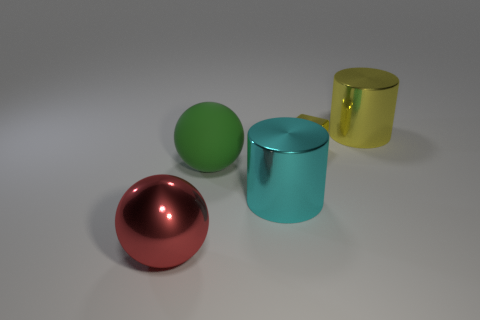Is there any other thing that has the same size as the cube?
Your answer should be very brief. No. What size is the shiny thing left of the big green thing?
Make the answer very short. Large. Is the number of small yellow metallic cubes less than the number of large yellow blocks?
Ensure brevity in your answer.  No. Is there a large matte object that has the same color as the small metallic block?
Provide a short and direct response. No. There is a large thing that is both to the right of the green thing and in front of the large yellow cylinder; what is its shape?
Give a very brief answer. Cylinder. There is a yellow thing that is to the left of the thing that is behind the metal cube; what is its shape?
Ensure brevity in your answer.  Cube. Is the shape of the green object the same as the tiny metal object?
Give a very brief answer. No. What material is the cylinder that is the same color as the tiny metallic object?
Your answer should be very brief. Metal. Do the small shiny block and the large rubber thing have the same color?
Give a very brief answer. No. There is a large metal cylinder that is in front of the large thing on the right side of the cyan metallic object; what number of balls are behind it?
Make the answer very short. 1. 